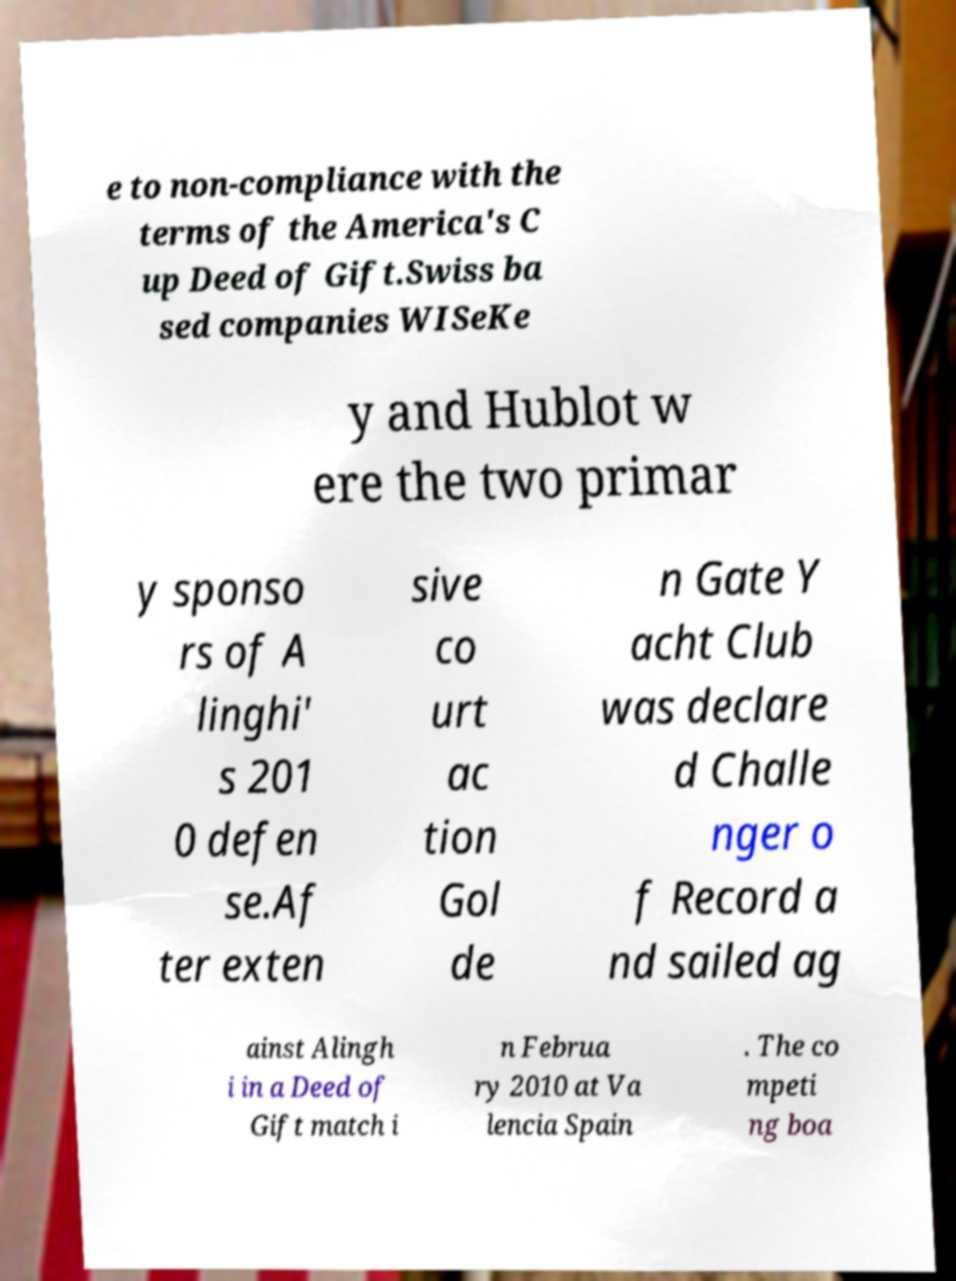What messages or text are displayed in this image? I need them in a readable, typed format. e to non-compliance with the terms of the America's C up Deed of Gift.Swiss ba sed companies WISeKe y and Hublot w ere the two primar y sponso rs of A linghi' s 201 0 defen se.Af ter exten sive co urt ac tion Gol de n Gate Y acht Club was declare d Challe nger o f Record a nd sailed ag ainst Alingh i in a Deed of Gift match i n Februa ry 2010 at Va lencia Spain . The co mpeti ng boa 